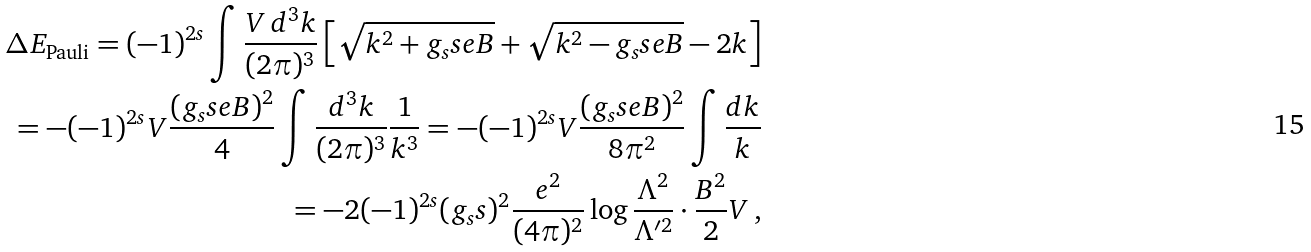<formula> <loc_0><loc_0><loc_500><loc_500>\Delta E _ { \text {Pauli} } = ( - 1 ) ^ { 2 s } \int \frac { V \, d ^ { 3 } k } { ( 2 \pi ) ^ { 3 } } \left [ \sqrt { k ^ { 2 } + g _ { s } s e B } + \sqrt { k ^ { 2 } - g _ { s } s e B } - 2 k \right ] \\ = - ( - 1 ) ^ { 2 s } V \frac { ( g _ { s } s e B ) ^ { 2 } } { 4 } \int \frac { d ^ { 3 } k } { ( 2 \pi ) ^ { 3 } } \frac { 1 } { k ^ { 3 } } = - ( - 1 ) ^ { 2 s } V \frac { ( g _ { s } s e B ) ^ { 2 } } { 8 \pi ^ { 2 } } \int \frac { d k } { k } \\ = - 2 ( - 1 ) ^ { 2 s } ( g _ { s } s ) ^ { 2 } \frac { e ^ { 2 } } { ( 4 \pi ) ^ { 2 } } \log \frac { \Lambda ^ { 2 } } { \Lambda ^ { \prime 2 } } \cdot \frac { B ^ { 2 } } { 2 } V \, ,</formula> 